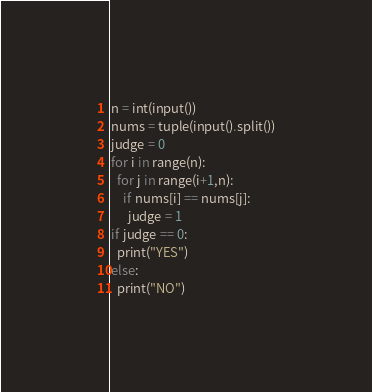<code> <loc_0><loc_0><loc_500><loc_500><_Python_>n = int(input())
nums = tuple(input().split())
judge = 0
for i in range(n):
  for j in range(i+1,n):
    if nums[i] == nums[j]:
      judge = 1
if judge == 0:
  print("YES")
else:
  print("NO")</code> 